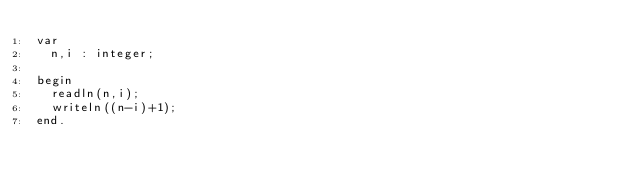<code> <loc_0><loc_0><loc_500><loc_500><_Pascal_>var
	n,i : integer;
	
begin
	readln(n,i);
	writeln((n-i)+1);
end.</code> 